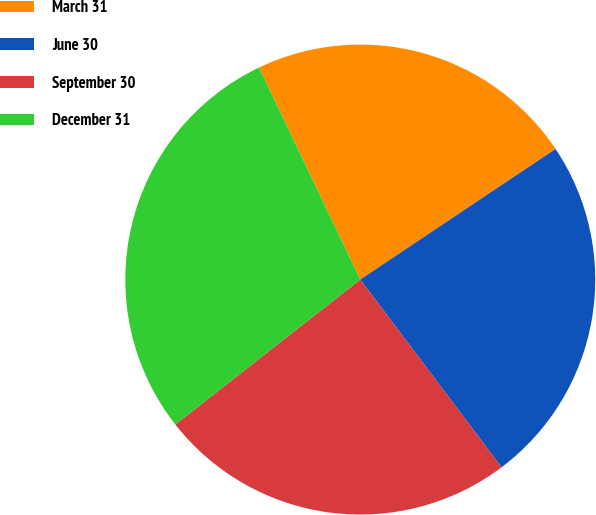<chart> <loc_0><loc_0><loc_500><loc_500><pie_chart><fcel>March 31<fcel>June 30<fcel>September 30<fcel>December 31<nl><fcel>22.71%<fcel>24.11%<fcel>24.69%<fcel>28.49%<nl></chart> 